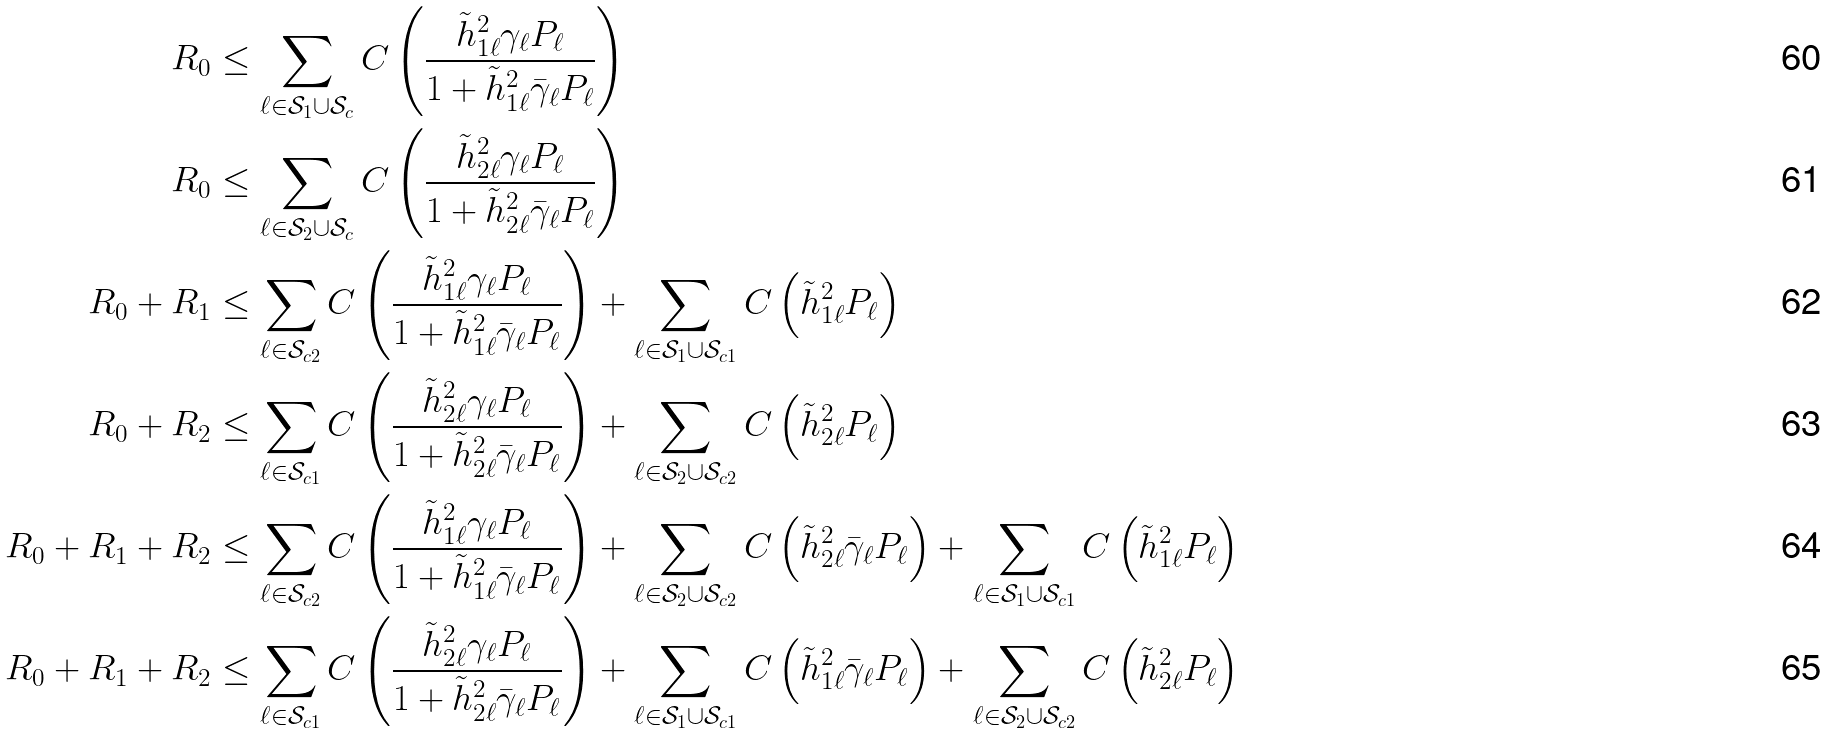Convert formula to latex. <formula><loc_0><loc_0><loc_500><loc_500>R _ { 0 } & \leq \sum _ { \ell \in \mathcal { S } _ { 1 } \cup \mathcal { S } _ { c } } C \left ( \frac { \tilde { h } _ { 1 \ell } ^ { 2 } \gamma _ { \ell } P _ { \ell } } { 1 + \tilde { h } _ { 1 \ell } ^ { 2 } \bar { \gamma } _ { \ell } P _ { \ell } } \right ) \\ R _ { 0 } & \leq \sum _ { \ell \in \mathcal { S } _ { 2 } \cup \mathcal { S } _ { c } } C \left ( \frac { \tilde { h } _ { 2 \ell } ^ { 2 } \gamma _ { \ell } P _ { \ell } } { 1 + \tilde { h } _ { 2 \ell } ^ { 2 } \bar { \gamma } _ { \ell } P _ { \ell } } \right ) \\ R _ { 0 } + R _ { 1 } & \leq \sum _ { \ell \in \mathcal { S } _ { c 2 } } C \left ( \frac { \tilde { h } _ { 1 \ell } ^ { 2 } \gamma _ { \ell } P _ { \ell } } { 1 + \tilde { h } _ { 1 \ell } ^ { 2 } \bar { \gamma } _ { \ell } P _ { \ell } } \right ) + \sum _ { \ell \in \mathcal { S } _ { 1 } \cup \mathcal { S } _ { c 1 } } C \left ( \tilde { h } _ { 1 \ell } ^ { 2 } P _ { \ell } \right ) \\ R _ { 0 } + R _ { 2 } & \leq \sum _ { \ell \in \mathcal { S } _ { c 1 } } C \left ( \frac { \tilde { h } _ { 2 \ell } ^ { 2 } \gamma _ { \ell } P _ { \ell } } { 1 + \tilde { h } _ { 2 \ell } ^ { 2 } \bar { \gamma } _ { \ell } P _ { \ell } } \right ) + \sum _ { \ell \in \mathcal { S } _ { 2 } \cup \mathcal { S } _ { c 2 } } C \left ( \tilde { h } _ { 2 \ell } ^ { 2 } P _ { \ell } \right ) \\ R _ { 0 } + R _ { 1 } + R _ { 2 } & \leq \sum _ { \ell \in \mathcal { S } _ { c 2 } } C \left ( \frac { \tilde { h } _ { 1 \ell } ^ { 2 } \gamma _ { \ell } P _ { \ell } } { 1 + \tilde { h } _ { 1 \ell } ^ { 2 } \bar { \gamma } _ { \ell } P _ { \ell } } \right ) + \sum _ { \ell \in \mathcal { S } _ { 2 } \cup \mathcal { S } _ { c 2 } } C \left ( \tilde { h } _ { 2 \ell } ^ { 2 } \bar { \gamma } _ { \ell } P _ { \ell } \right ) + \sum _ { \ell \in \mathcal { S } _ { 1 } \cup \mathcal { S } _ { c 1 } } C \left ( \tilde { h } _ { 1 \ell } ^ { 2 } P _ { \ell } \right ) \\ R _ { 0 } + R _ { 1 } + R _ { 2 } & \leq \sum _ { \ell \in \mathcal { S } _ { c 1 } } C \left ( \frac { \tilde { h } _ { 2 \ell } ^ { 2 } \gamma _ { \ell } P _ { \ell } } { 1 + \tilde { h } _ { 2 \ell } ^ { 2 } \bar { \gamma } _ { \ell } P _ { \ell } } \right ) + \sum _ { \ell \in \mathcal { S } _ { 1 } \cup \mathcal { S } _ { c 1 } } C \left ( \tilde { h } _ { 1 \ell } ^ { 2 } \bar { \gamma } _ { \ell } P _ { \ell } \right ) + \sum _ { \ell \in \mathcal { S } _ { 2 } \cup \mathcal { S } _ { c 2 } } C \left ( \tilde { h } _ { 2 \ell } ^ { 2 } P _ { \ell } \right )</formula> 